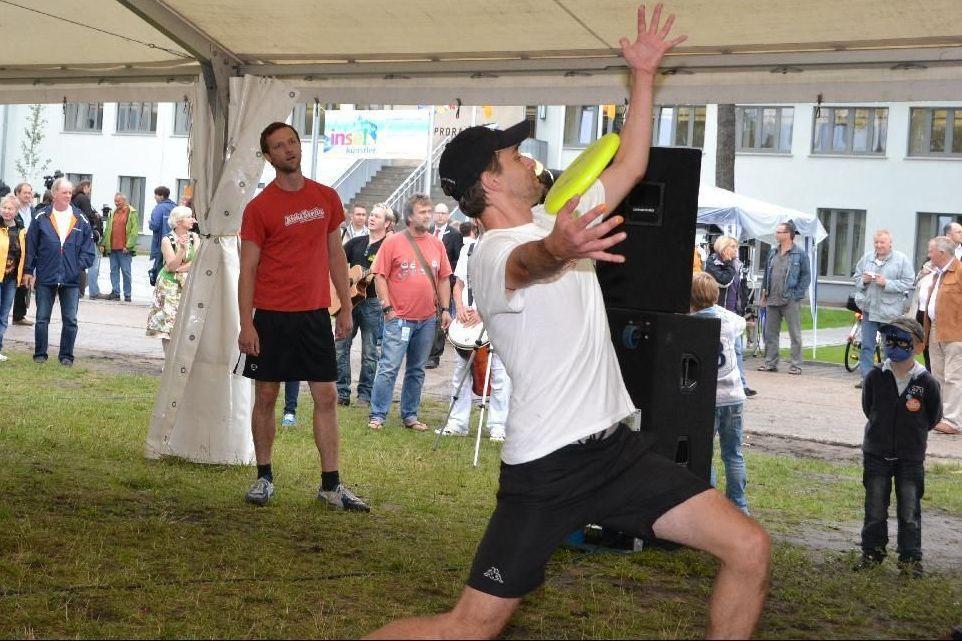How many people have face paint on?
Give a very brief answer. 1. How many childrens are there in the image?
Give a very brief answer. 2. 